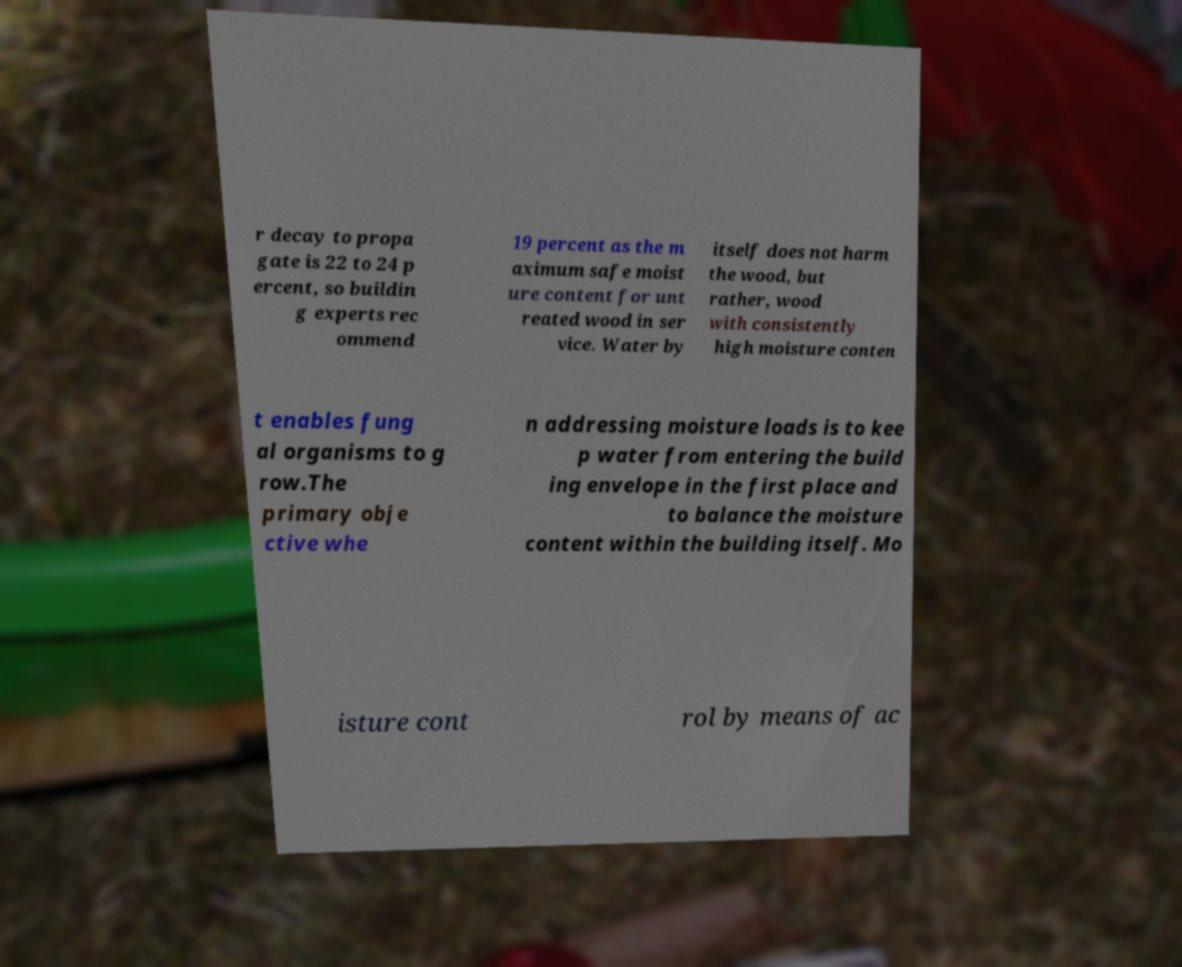Please read and relay the text visible in this image. What does it say? r decay to propa gate is 22 to 24 p ercent, so buildin g experts rec ommend 19 percent as the m aximum safe moist ure content for unt reated wood in ser vice. Water by itself does not harm the wood, but rather, wood with consistently high moisture conten t enables fung al organisms to g row.The primary obje ctive whe n addressing moisture loads is to kee p water from entering the build ing envelope in the first place and to balance the moisture content within the building itself. Mo isture cont rol by means of ac 